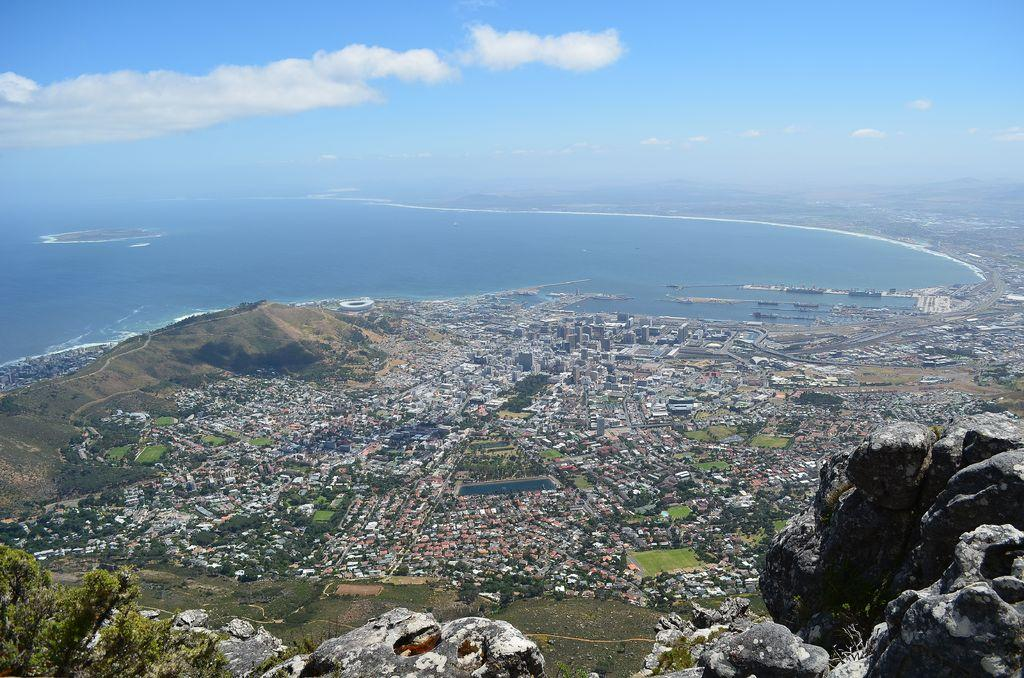What city is the main subject of the image? The image contains Cape Town in the center. What part of the natural environment is visible in the image? There are rocks at the bottom of the image. What is visible at the top of the image? There is sky visible at the top of the image. How many attempts did the size of the Cape Town make to laugh in the image? There are no birds or animals in the image, so the concept of laughter does not apply. 